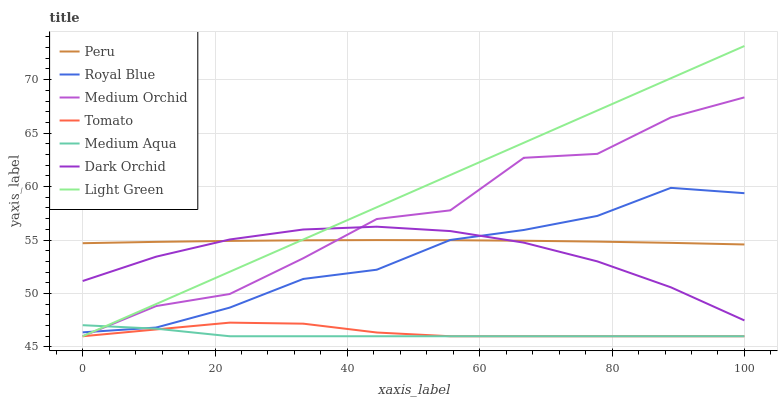Does Medium Orchid have the minimum area under the curve?
Answer yes or no. No. Does Medium Orchid have the maximum area under the curve?
Answer yes or no. No. Is Medium Orchid the smoothest?
Answer yes or no. No. Is Light Green the roughest?
Answer yes or no. No. Does Dark Orchid have the lowest value?
Answer yes or no. No. Does Medium Orchid have the highest value?
Answer yes or no. No. Is Tomato less than Dark Orchid?
Answer yes or no. Yes. Is Peru greater than Medium Aqua?
Answer yes or no. Yes. Does Tomato intersect Dark Orchid?
Answer yes or no. No. 